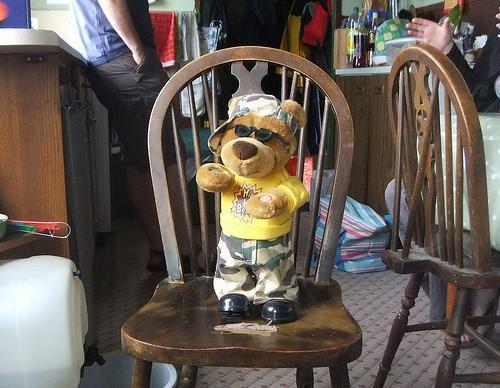How many people are in the room?
Give a very brief answer. 2. 